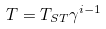Convert formula to latex. <formula><loc_0><loc_0><loc_500><loc_500>T = T _ { S T } \gamma ^ { i - 1 }</formula> 